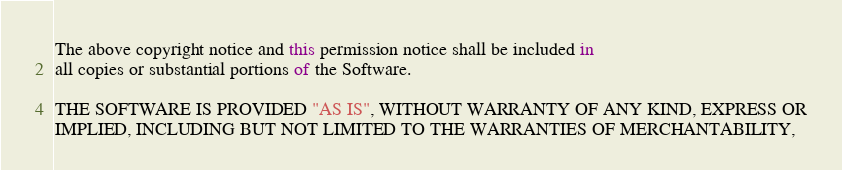<code> <loc_0><loc_0><loc_500><loc_500><_JavaScript_>
The above copyright notice and this permission notice shall be included in
all copies or substantial portions of the Software.

THE SOFTWARE IS PROVIDED "AS IS", WITHOUT WARRANTY OF ANY KIND, EXPRESS OR
IMPLIED, INCLUDING BUT NOT LIMITED TO THE WARRANTIES OF MERCHANTABILITY,</code> 